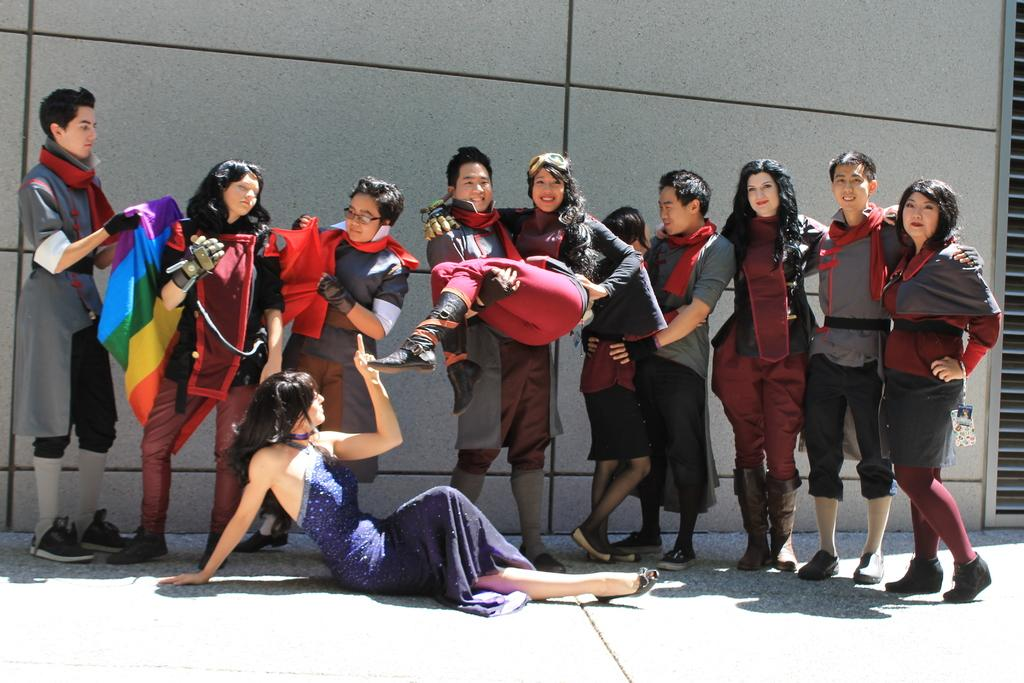What can be seen in the image? There is a group of people and a building in the image. What is the man on the left side of the image doing? The man is holding a cloth on the left side of the image. What type of underwear is the farmer wearing in the image? There is no farmer or underwear present in the image. How is the division between the people and the building represented in the image? The image does not depict a division between the people and the building; they are all visible within the same frame. 